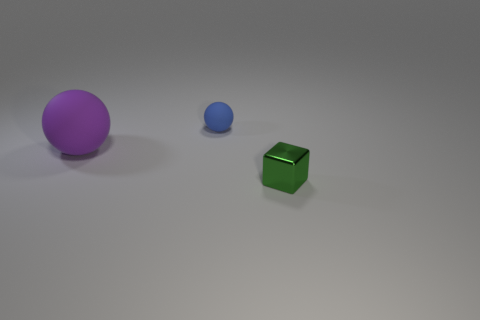Add 3 cubes. How many objects exist? 6 Subtract all blocks. How many objects are left? 2 Add 1 large balls. How many large balls exist? 2 Subtract 0 red blocks. How many objects are left? 3 Subtract all red spheres. Subtract all brown cylinders. How many spheres are left? 2 Subtract all metallic things. Subtract all matte balls. How many objects are left? 0 Add 1 big matte things. How many big matte things are left? 2 